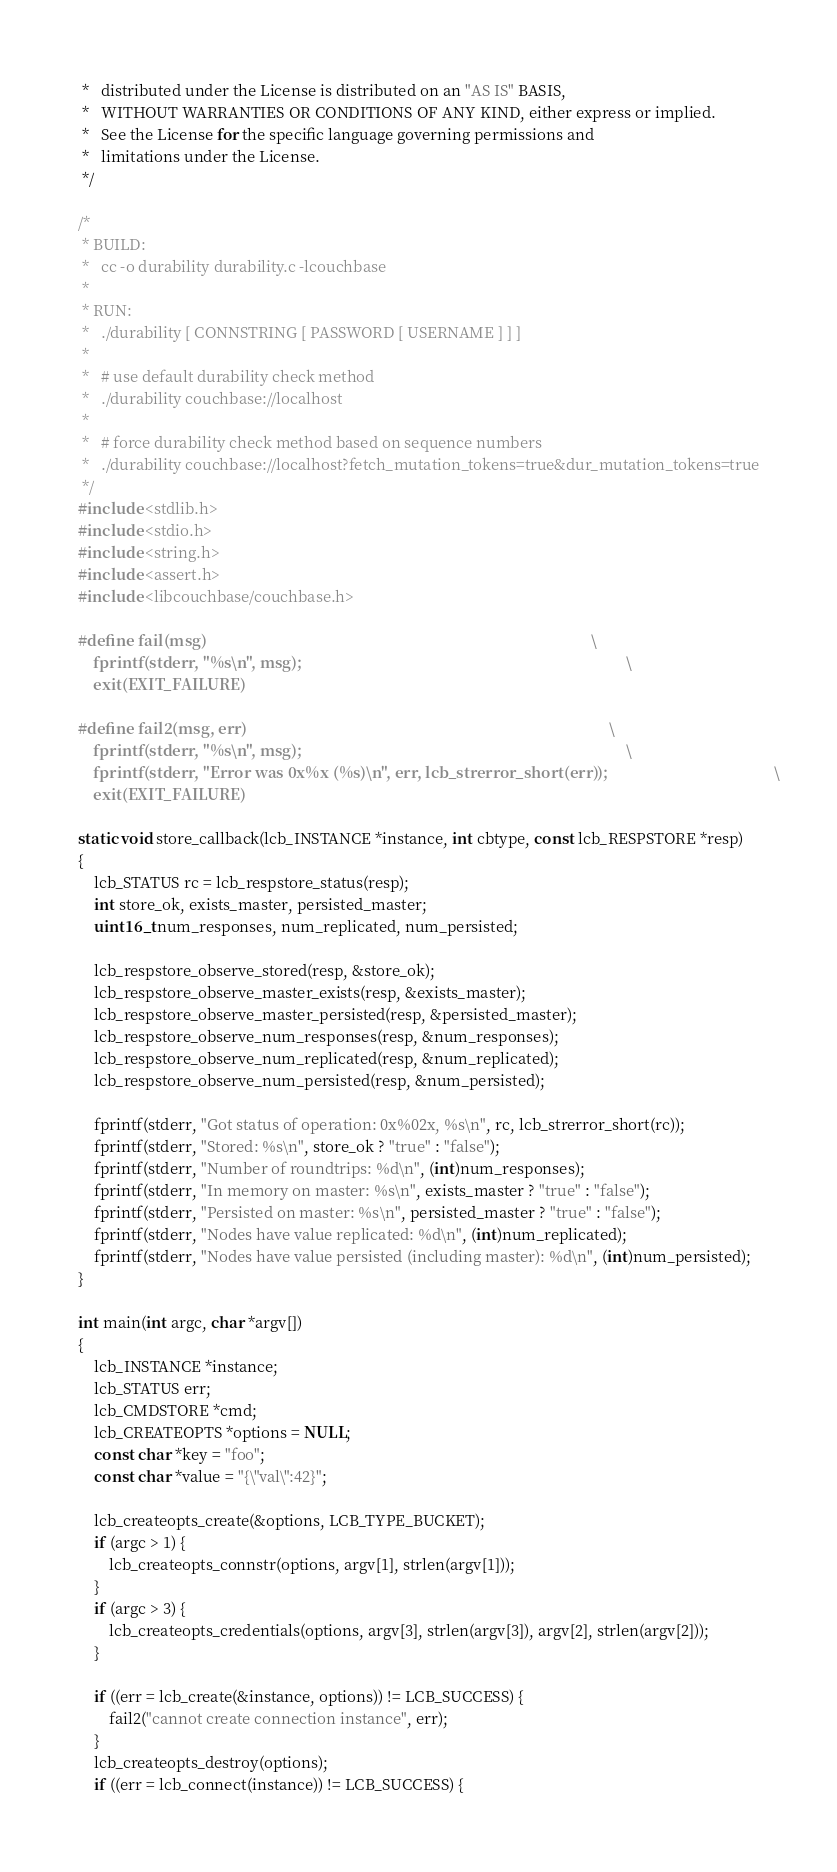Convert code to text. <code><loc_0><loc_0><loc_500><loc_500><_C_> *   distributed under the License is distributed on an "AS IS" BASIS,
 *   WITHOUT WARRANTIES OR CONDITIONS OF ANY KIND, either express or implied.
 *   See the License for the specific language governing permissions and
 *   limitations under the License.
 */

/*
 * BUILD:
 *   cc -o durability durability.c -lcouchbase
 *
 * RUN:
 *   ./durability [ CONNSTRING [ PASSWORD [ USERNAME ] ] ]
 *
 *   # use default durability check method
 *   ./durability couchbase://localhost
 *
 *   # force durability check method based on sequence numbers
 *   ./durability couchbase://localhost?fetch_mutation_tokens=true&dur_mutation_tokens=true
 */
#include <stdlib.h>
#include <stdio.h>
#include <string.h>
#include <assert.h>
#include <libcouchbase/couchbase.h>

#define fail(msg)                                                                                                      \
    fprintf(stderr, "%s\n", msg);                                                                                      \
    exit(EXIT_FAILURE)

#define fail2(msg, err)                                                                                                \
    fprintf(stderr, "%s\n", msg);                                                                                      \
    fprintf(stderr, "Error was 0x%x (%s)\n", err, lcb_strerror_short(err));                                            \
    exit(EXIT_FAILURE)

static void store_callback(lcb_INSTANCE *instance, int cbtype, const lcb_RESPSTORE *resp)
{
    lcb_STATUS rc = lcb_respstore_status(resp);
    int store_ok, exists_master, persisted_master;
    uint16_t num_responses, num_replicated, num_persisted;

    lcb_respstore_observe_stored(resp, &store_ok);
    lcb_respstore_observe_master_exists(resp, &exists_master);
    lcb_respstore_observe_master_persisted(resp, &persisted_master);
    lcb_respstore_observe_num_responses(resp, &num_responses);
    lcb_respstore_observe_num_replicated(resp, &num_replicated);
    lcb_respstore_observe_num_persisted(resp, &num_persisted);

    fprintf(stderr, "Got status of operation: 0x%02x, %s\n", rc, lcb_strerror_short(rc));
    fprintf(stderr, "Stored: %s\n", store_ok ? "true" : "false");
    fprintf(stderr, "Number of roundtrips: %d\n", (int)num_responses);
    fprintf(stderr, "In memory on master: %s\n", exists_master ? "true" : "false");
    fprintf(stderr, "Persisted on master: %s\n", persisted_master ? "true" : "false");
    fprintf(stderr, "Nodes have value replicated: %d\n", (int)num_replicated);
    fprintf(stderr, "Nodes have value persisted (including master): %d\n", (int)num_persisted);
}

int main(int argc, char *argv[])
{
    lcb_INSTANCE *instance;
    lcb_STATUS err;
    lcb_CMDSTORE *cmd;
    lcb_CREATEOPTS *options = NULL;
    const char *key = "foo";
    const char *value = "{\"val\":42}";

    lcb_createopts_create(&options, LCB_TYPE_BUCKET);
    if (argc > 1) {
        lcb_createopts_connstr(options, argv[1], strlen(argv[1]));
    }
    if (argc > 3) {
        lcb_createopts_credentials(options, argv[3], strlen(argv[3]), argv[2], strlen(argv[2]));
    }

    if ((err = lcb_create(&instance, options)) != LCB_SUCCESS) {
        fail2("cannot create connection instance", err);
    }
    lcb_createopts_destroy(options);
    if ((err = lcb_connect(instance)) != LCB_SUCCESS) {</code> 